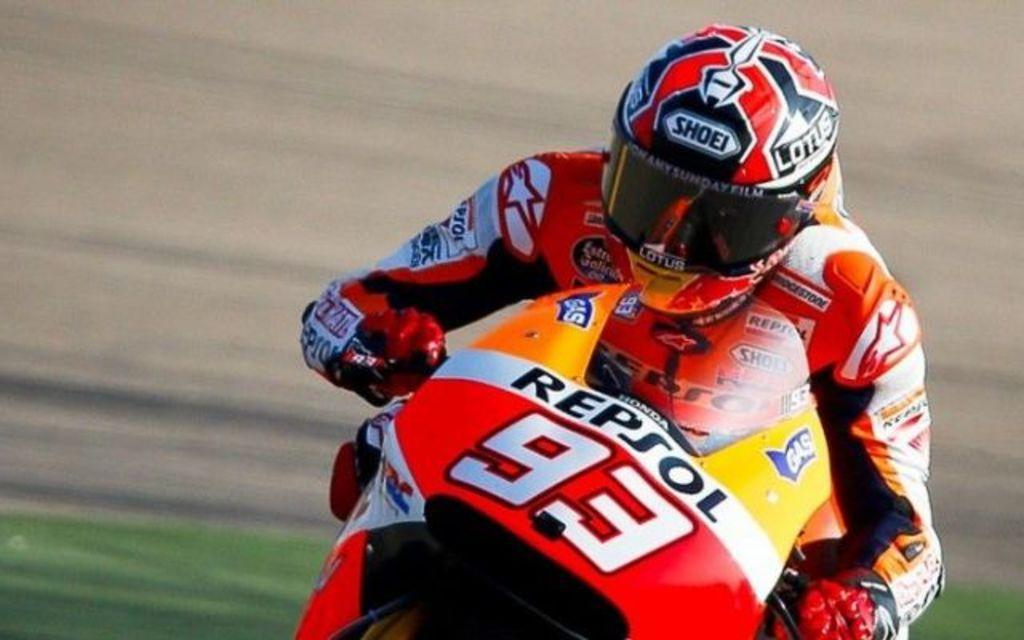Describe this image in one or two sentences. In this image a person is sitting on the bike. He is wearing helmet and gloves. He is riding on the road. Beside him there is grassland. 